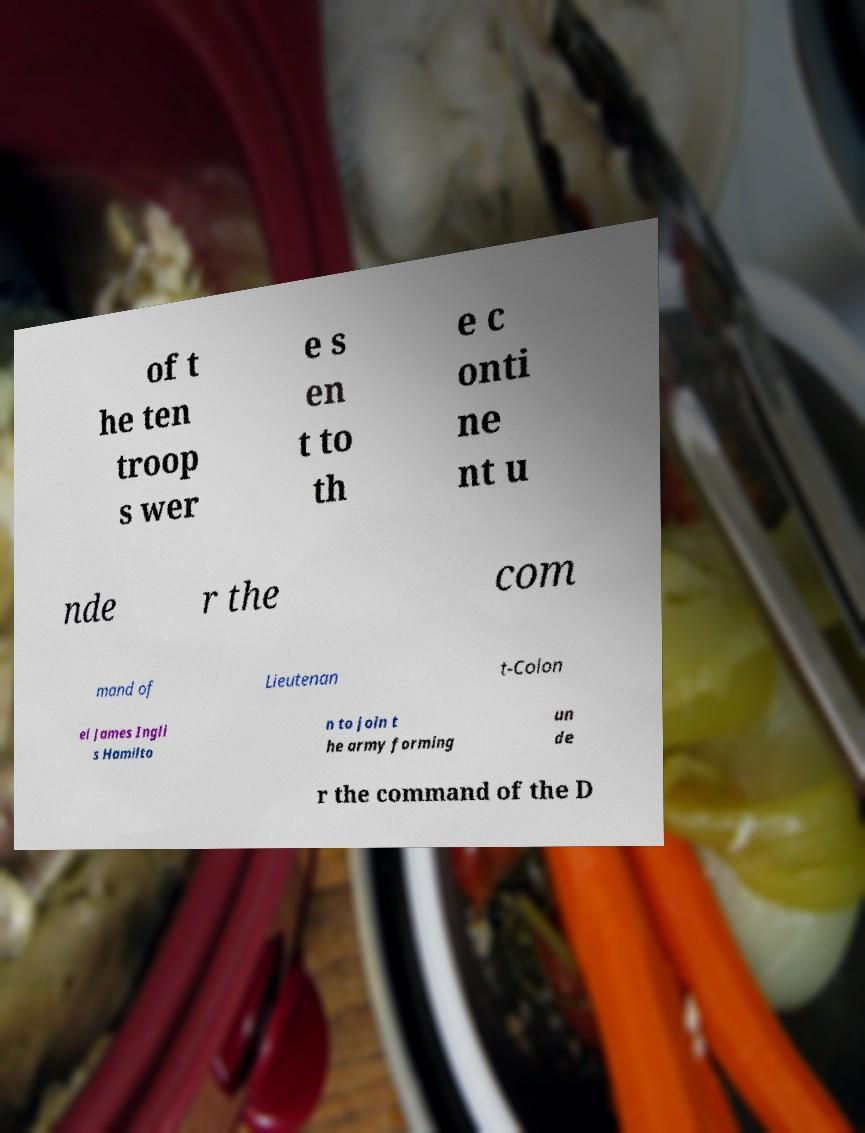I need the written content from this picture converted into text. Can you do that? of t he ten troop s wer e s en t to th e c onti ne nt u nde r the com mand of Lieutenan t-Colon el James Ingli s Hamilto n to join t he army forming un de r the command of the D 